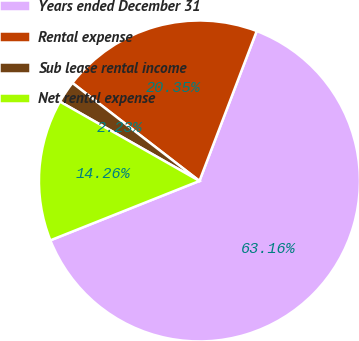Convert chart. <chart><loc_0><loc_0><loc_500><loc_500><pie_chart><fcel>Years ended December 31<fcel>Rental expense<fcel>Sub lease rental income<fcel>Net rental expense<nl><fcel>63.16%<fcel>20.35%<fcel>2.23%<fcel>14.26%<nl></chart> 